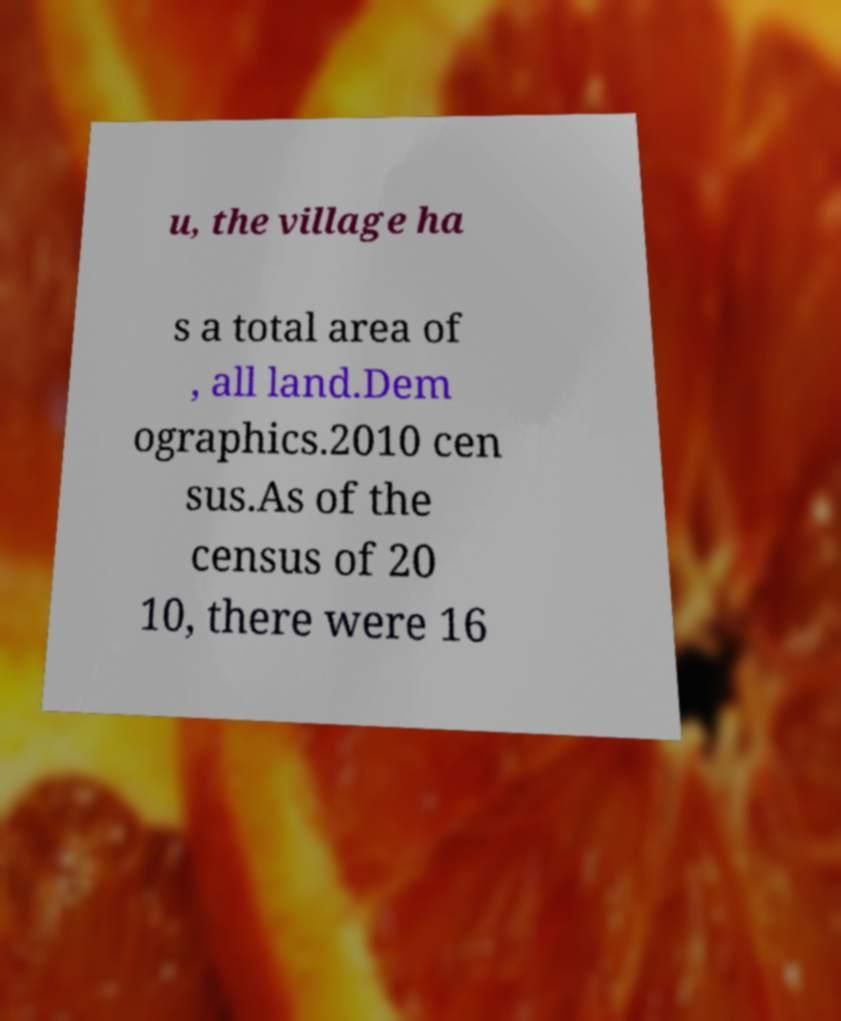For documentation purposes, I need the text within this image transcribed. Could you provide that? u, the village ha s a total area of , all land.Dem ographics.2010 cen sus.As of the census of 20 10, there were 16 